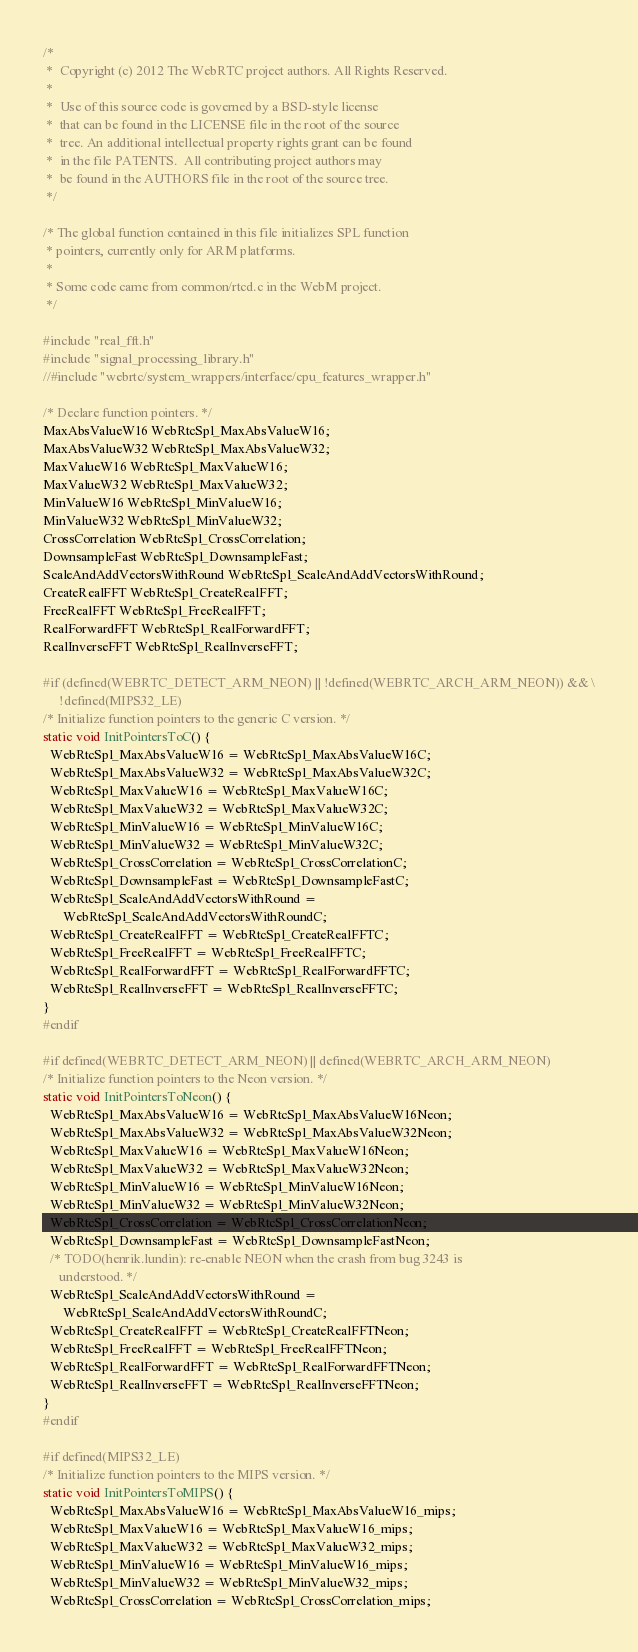<code> <loc_0><loc_0><loc_500><loc_500><_C_>/*
 *  Copyright (c) 2012 The WebRTC project authors. All Rights Reserved.
 *
 *  Use of this source code is governed by a BSD-style license
 *  that can be found in the LICENSE file in the root of the source
 *  tree. An additional intellectual property rights grant can be found
 *  in the file PATENTS.  All contributing project authors may
 *  be found in the AUTHORS file in the root of the source tree.
 */

/* The global function contained in this file initializes SPL function
 * pointers, currently only for ARM platforms.
 *
 * Some code came from common/rtcd.c in the WebM project.
 */

#include "real_fft.h"
#include "signal_processing_library.h"
//#include "webrtc/system_wrappers/interface/cpu_features_wrapper.h"

/* Declare function pointers. */
MaxAbsValueW16 WebRtcSpl_MaxAbsValueW16;
MaxAbsValueW32 WebRtcSpl_MaxAbsValueW32;
MaxValueW16 WebRtcSpl_MaxValueW16;
MaxValueW32 WebRtcSpl_MaxValueW32;
MinValueW16 WebRtcSpl_MinValueW16;
MinValueW32 WebRtcSpl_MinValueW32;
CrossCorrelation WebRtcSpl_CrossCorrelation;
DownsampleFast WebRtcSpl_DownsampleFast;
ScaleAndAddVectorsWithRound WebRtcSpl_ScaleAndAddVectorsWithRound;
CreateRealFFT WebRtcSpl_CreateRealFFT;
FreeRealFFT WebRtcSpl_FreeRealFFT;
RealForwardFFT WebRtcSpl_RealForwardFFT;
RealInverseFFT WebRtcSpl_RealInverseFFT;

#if (defined(WEBRTC_DETECT_ARM_NEON) || !defined(WEBRTC_ARCH_ARM_NEON)) && \
     !defined(MIPS32_LE)
/* Initialize function pointers to the generic C version. */
static void InitPointersToC() {
  WebRtcSpl_MaxAbsValueW16 = WebRtcSpl_MaxAbsValueW16C;
  WebRtcSpl_MaxAbsValueW32 = WebRtcSpl_MaxAbsValueW32C;
  WebRtcSpl_MaxValueW16 = WebRtcSpl_MaxValueW16C;
  WebRtcSpl_MaxValueW32 = WebRtcSpl_MaxValueW32C;
  WebRtcSpl_MinValueW16 = WebRtcSpl_MinValueW16C;
  WebRtcSpl_MinValueW32 = WebRtcSpl_MinValueW32C;
  WebRtcSpl_CrossCorrelation = WebRtcSpl_CrossCorrelationC;
  WebRtcSpl_DownsampleFast = WebRtcSpl_DownsampleFastC;
  WebRtcSpl_ScaleAndAddVectorsWithRound =
      WebRtcSpl_ScaleAndAddVectorsWithRoundC;
  WebRtcSpl_CreateRealFFT = WebRtcSpl_CreateRealFFTC;
  WebRtcSpl_FreeRealFFT = WebRtcSpl_FreeRealFFTC;
  WebRtcSpl_RealForwardFFT = WebRtcSpl_RealForwardFFTC;
  WebRtcSpl_RealInverseFFT = WebRtcSpl_RealInverseFFTC;
}
#endif

#if defined(WEBRTC_DETECT_ARM_NEON) || defined(WEBRTC_ARCH_ARM_NEON)
/* Initialize function pointers to the Neon version. */
static void InitPointersToNeon() {
  WebRtcSpl_MaxAbsValueW16 = WebRtcSpl_MaxAbsValueW16Neon;
  WebRtcSpl_MaxAbsValueW32 = WebRtcSpl_MaxAbsValueW32Neon;
  WebRtcSpl_MaxValueW16 = WebRtcSpl_MaxValueW16Neon;
  WebRtcSpl_MaxValueW32 = WebRtcSpl_MaxValueW32Neon;
  WebRtcSpl_MinValueW16 = WebRtcSpl_MinValueW16Neon;
  WebRtcSpl_MinValueW32 = WebRtcSpl_MinValueW32Neon;
  WebRtcSpl_CrossCorrelation = WebRtcSpl_CrossCorrelationNeon;
  WebRtcSpl_DownsampleFast = WebRtcSpl_DownsampleFastNeon;
  /* TODO(henrik.lundin): re-enable NEON when the crash from bug 3243 is
     understood. */
  WebRtcSpl_ScaleAndAddVectorsWithRound =
      WebRtcSpl_ScaleAndAddVectorsWithRoundC;
  WebRtcSpl_CreateRealFFT = WebRtcSpl_CreateRealFFTNeon;
  WebRtcSpl_FreeRealFFT = WebRtcSpl_FreeRealFFTNeon;
  WebRtcSpl_RealForwardFFT = WebRtcSpl_RealForwardFFTNeon;
  WebRtcSpl_RealInverseFFT = WebRtcSpl_RealInverseFFTNeon;
}
#endif

#if defined(MIPS32_LE)
/* Initialize function pointers to the MIPS version. */
static void InitPointersToMIPS() {
  WebRtcSpl_MaxAbsValueW16 = WebRtcSpl_MaxAbsValueW16_mips;
  WebRtcSpl_MaxValueW16 = WebRtcSpl_MaxValueW16_mips;
  WebRtcSpl_MaxValueW32 = WebRtcSpl_MaxValueW32_mips;
  WebRtcSpl_MinValueW16 = WebRtcSpl_MinValueW16_mips;
  WebRtcSpl_MinValueW32 = WebRtcSpl_MinValueW32_mips;
  WebRtcSpl_CrossCorrelation = WebRtcSpl_CrossCorrelation_mips;</code> 